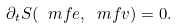Convert formula to latex. <formula><loc_0><loc_0><loc_500><loc_500>\partial _ { t } S ( { \ m f e } , { \ m f v } ) = 0 .</formula> 